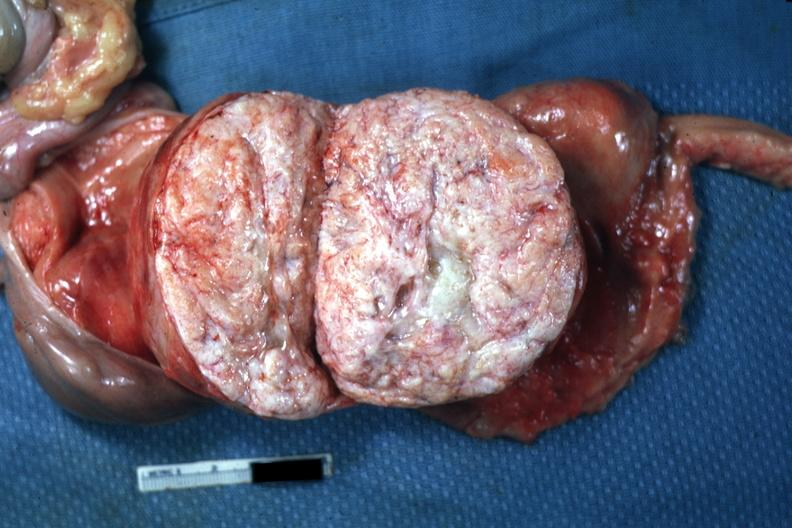what has been sliced open like book can not readily see uterus itself myoma lesion is quite typical close-up photo?
Answer the question using a single word or phrase. This 